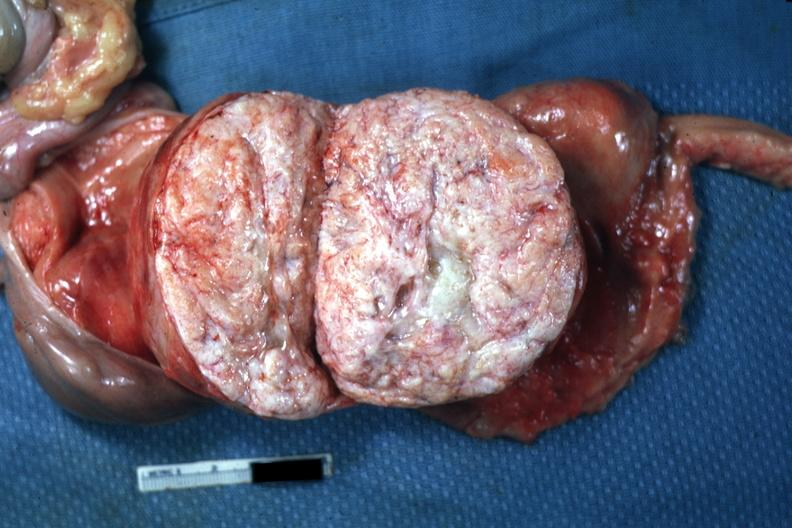what has been sliced open like book can not readily see uterus itself myoma lesion is quite typical close-up photo?
Answer the question using a single word or phrase. This 